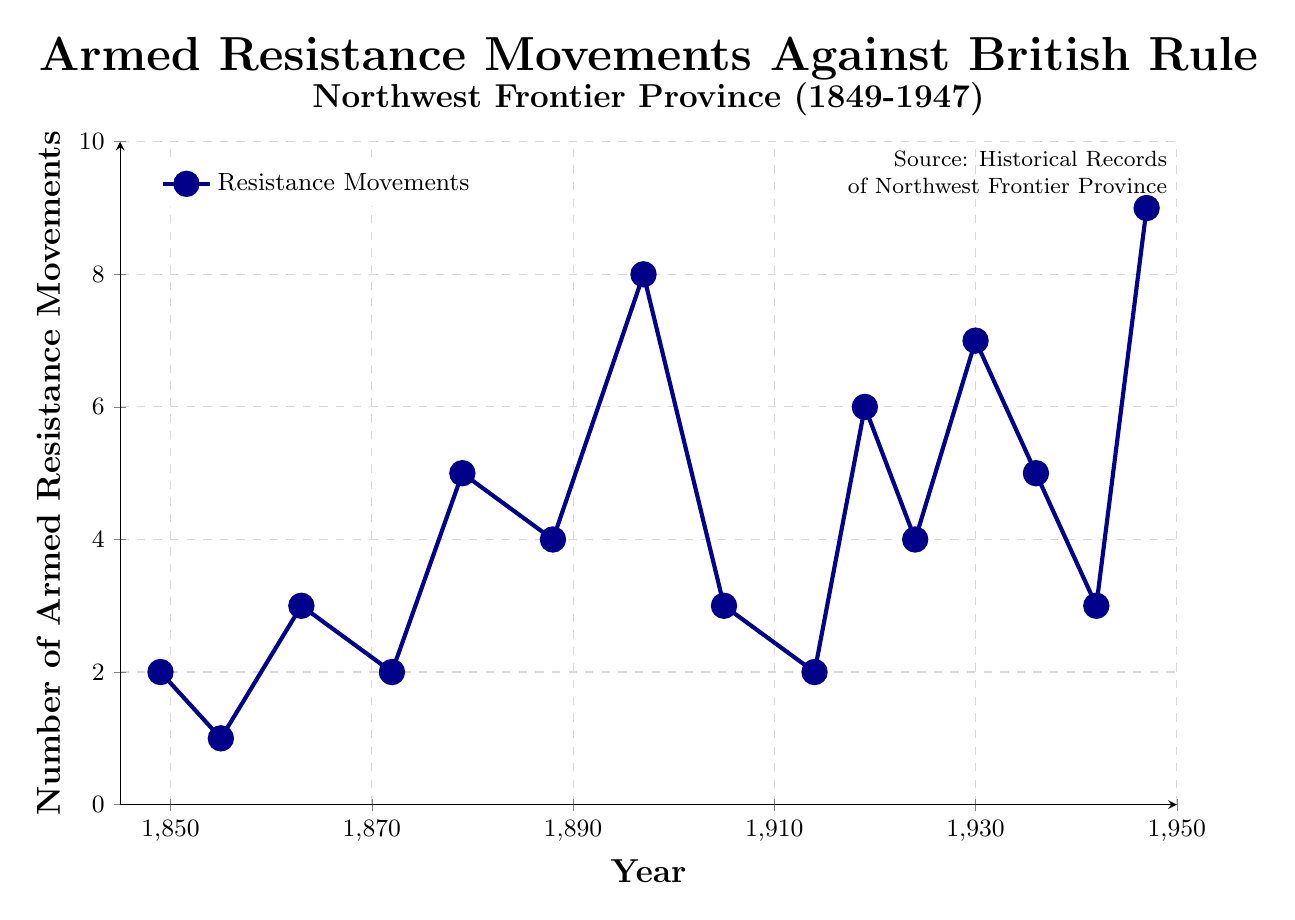What year experienced the highest number of armed resistance movements? The figure shows the number of armed resistance movements on the y-axis for each year on the x-axis. The year with the highest value on the y-axis is 1947, which corresponds to 9 movements.
Answer: 1947 How many years had exactly 5 armed resistance movements? The figure shows the number of movements for each year. Counting the years where the y-axis value equals 5, we have 1879, 1936. Therefore, there are 2 years.
Answer: 2 Which period has a higher average number of resistance movements, 1849-1888 or 1905-1947? Calculate the average number of movements for the years 1849 to 1888: (2 + 1 + 3 + 2 + 5 + 4) / 6 = 2.83. Calculate for 1905 to 1947: (3 + 2 + 6 + 4 + 7 + 5 + 3 + 9) / 8 = 4.88. Since 4.88 > 2.83, the period 1905-1947 has a higher average.
Answer: 1905-1947 In which decade did the number of armed resistance movements increase the most compared to the previous decade? Compare the increase in movements between each decade: From 1849-1859 (+1), 1860-1869 (+2), 1870-1879 (+3), 1880-1889 (-1), 1890-1899 (+1), 1900-1909 (-5), 1910-1919 (+4), 1920-1929 (-2), 1930-1939 (-2), 1940-1947 (+6). The highest increase is (1940-1947) with +6 movements.
Answer: 1940-1947 Which year had exactly double the movements compared to 1914? The figure shows 2 movements in 1914. Doubling this, we look for years with 4 movements, which are 1888 and 1924.
Answer: 1888, 1924 What is the total number of armed resistance movements from 1849 to 1947? Sum all movements in the given years: 2 + 1 + 3 + 2 + 5 + 4 + 8 + 3 + 2 + 6 + 4 + 7 + 5 + 3 + 9 = 64.
Answer: 64 How does the number of armed resistance movements in 1897 compare with that in 1924? The figure shows 8 movements in 1897 and 4 in 1924. Therefore, 1897 has double the number of movements compared to 1924.
Answer: Double Which years had fewer than 3 armed resistance movements? Looking at the figure, the years with fewer than 3 movements are: 1855 (1), 1849 (2), 1872 (2), 1914 (2).
Answer: 1855, 1849, 1872, 1914 What trends can be observed in armed resistance movements from 1849 to 1947? Observing the graph, there’s an initial period of low frequency, a notable peak around 1897, lower frequencies in the 1900s, another peak around 1919-1930, and the highest peak in 1947. Thus, a cyclical increase with the highest point in 1947 can be observed.
Answer: Cyclical increase, highest in 1947 